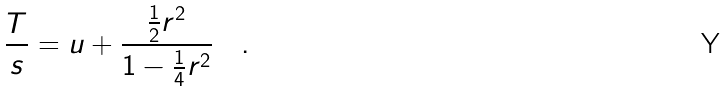Convert formula to latex. <formula><loc_0><loc_0><loc_500><loc_500>\frac { T } { s } = u + \frac { \frac { 1 } { 2 } r ^ { 2 } } { 1 - \frac { 1 } { 4 } r ^ { 2 } } \quad .</formula> 